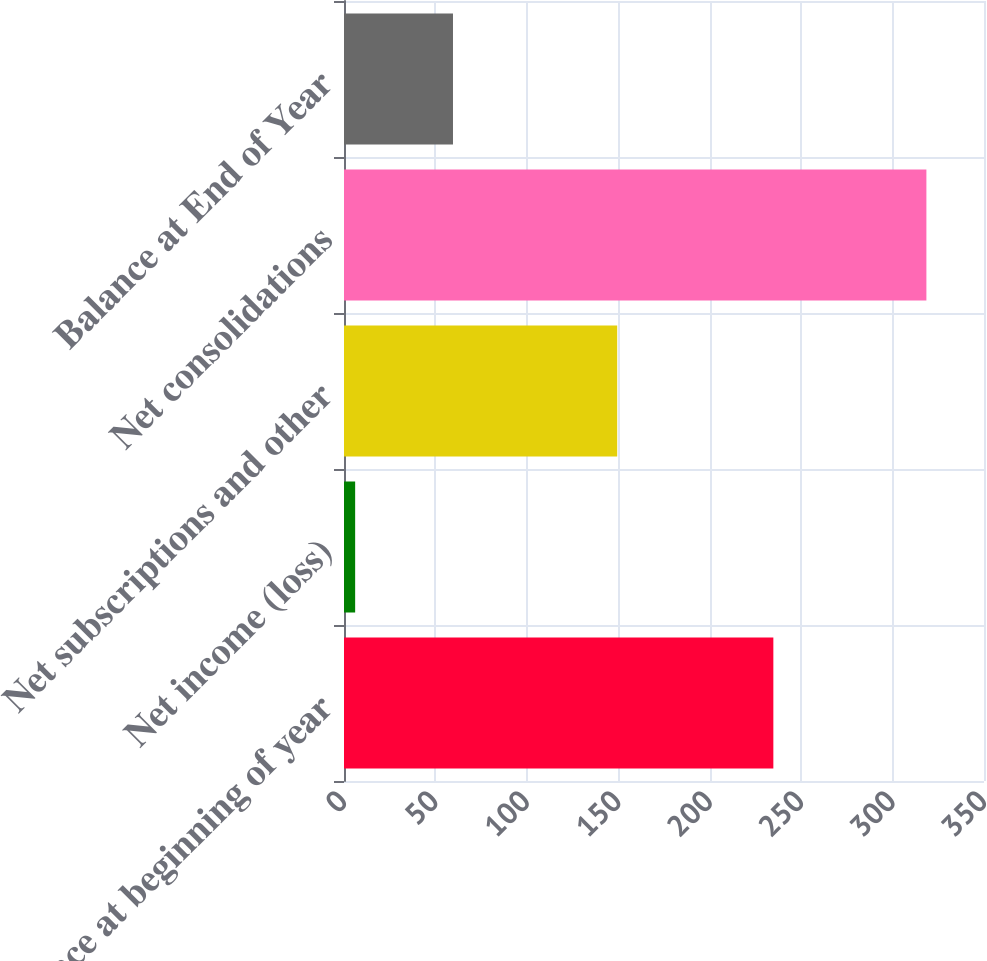Convert chart. <chart><loc_0><loc_0><loc_500><loc_500><bar_chart><fcel>Balance at beginning of year<fcel>Net income (loss)<fcel>Net subscriptions and other<fcel>Net consolidations<fcel>Balance at End of Year<nl><fcel>234.8<fcel>6.1<fcel>149.4<fcel>318.5<fcel>59.6<nl></chart> 